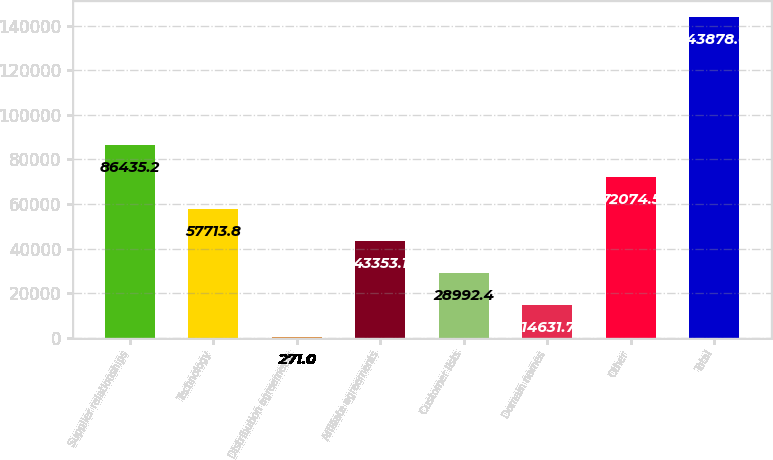Convert chart to OTSL. <chart><loc_0><loc_0><loc_500><loc_500><bar_chart><fcel>Supplier relationships<fcel>Technology<fcel>Distribution agreements<fcel>Affiliate agreements<fcel>Customer lists<fcel>Domain names<fcel>Other<fcel>Total<nl><fcel>86435.2<fcel>57713.8<fcel>271<fcel>43353.1<fcel>28992.4<fcel>14631.7<fcel>72074.5<fcel>143878<nl></chart> 